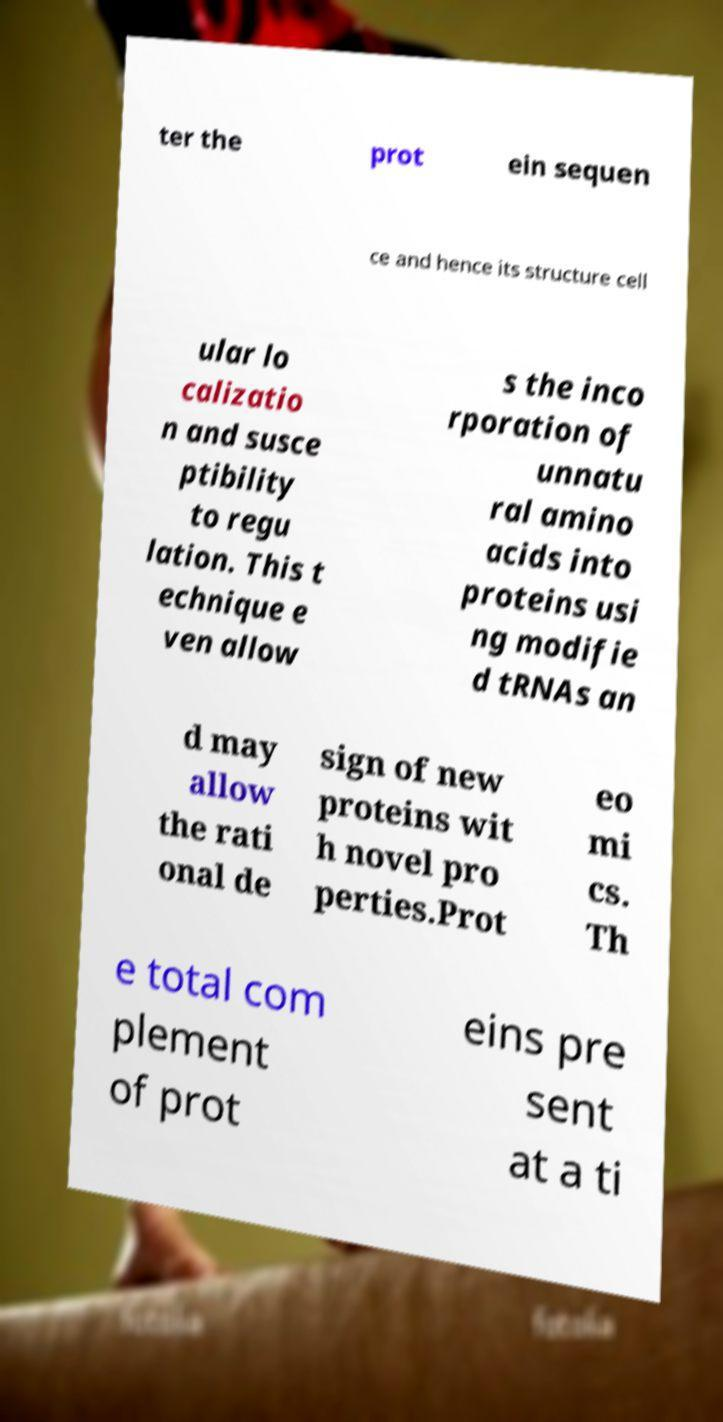I need the written content from this picture converted into text. Can you do that? ter the prot ein sequen ce and hence its structure cell ular lo calizatio n and susce ptibility to regu lation. This t echnique e ven allow s the inco rporation of unnatu ral amino acids into proteins usi ng modifie d tRNAs an d may allow the rati onal de sign of new proteins wit h novel pro perties.Prot eo mi cs. Th e total com plement of prot eins pre sent at a ti 